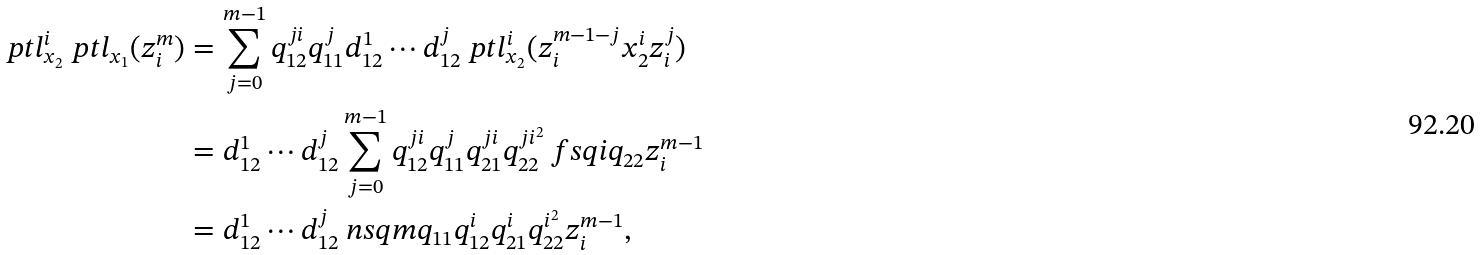<formula> <loc_0><loc_0><loc_500><loc_500>\ p t l _ { x _ { 2 } } ^ { i } \ p t l _ { x _ { 1 } } ( z _ { i } ^ { m } ) & = \sum _ { j = 0 } ^ { m - 1 } q _ { 1 2 } ^ { j i } q _ { 1 1 } ^ { j } d _ { 1 2 } ^ { 1 } \cdots d _ { 1 2 } ^ { j } \ p t l _ { x _ { 2 } } ^ { i } ( z _ { i } ^ { m - 1 - j } x _ { 2 } ^ { i } z _ { i } ^ { j } ) \\ & = d _ { 1 2 } ^ { 1 } \cdots d _ { 1 2 } ^ { j } \sum _ { j = 0 } ^ { m - 1 } q _ { 1 2 } ^ { j i } q _ { 1 1 } ^ { j } q _ { 2 1 } ^ { j i } q _ { 2 2 } ^ { j i ^ { 2 } } \ f s q i { q _ { 2 2 } } z _ { i } ^ { m - 1 } \\ & = d _ { 1 2 } ^ { 1 } \cdots d _ { 1 2 } ^ { j } \ n s q m { q _ { 1 1 } q _ { 1 2 } ^ { i } q _ { 2 1 } ^ { i } q _ { 2 2 } ^ { i ^ { 2 } } } z _ { i } ^ { m - 1 } ,</formula> 